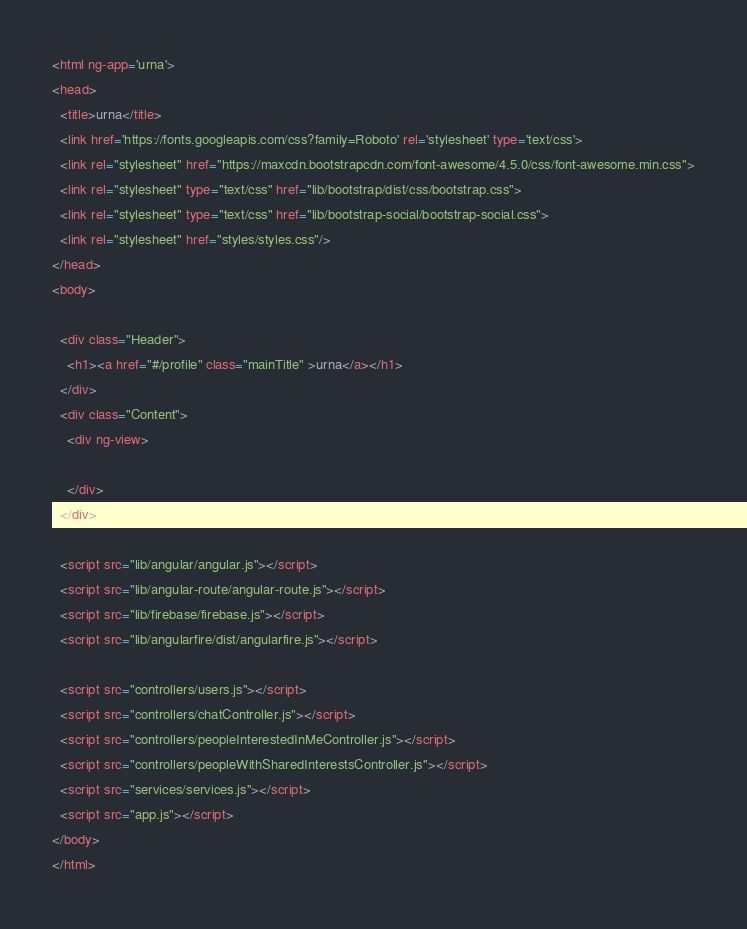Convert code to text. <code><loc_0><loc_0><loc_500><loc_500><_HTML_><html ng-app='urna'>
<head>
  <title>urna</title>
  <link href='https://fonts.googleapis.com/css?family=Roboto' rel='stylesheet' type='text/css'>
  <link rel="stylesheet" href="https://maxcdn.bootstrapcdn.com/font-awesome/4.5.0/css/font-awesome.min.css">
  <link rel="stylesheet" type="text/css" href="lib/bootstrap/dist/css/bootstrap.css">
  <link rel="stylesheet" type="text/css" href="lib/bootstrap-social/bootstrap-social.css">
  <link rel="stylesheet" href="styles/styles.css"/>
</head>
<body>

  <div class="Header">
    <h1><a href="#/profile" class="mainTitle" >urna</a></h1>
  </div>
  <div class="Content">
    <div ng-view>
      
    </div>
  </div>
  
  <script src="lib/angular/angular.js"></script>
  <script src="lib/angular-route/angular-route.js"></script>
  <script src="lib/firebase/firebase.js"></script>
  <script src="lib/angularfire/dist/angularfire.js"></script>

  <script src="controllers/users.js"></script>
  <script src="controllers/chatController.js"></script>
  <script src="controllers/peopleInterestedInMeController.js"></script>
  <script src="controllers/peopleWithSharedInterestsController.js"></script>
  <script src="services/services.js"></script>
  <script src="app.js"></script>
</body>
</html></code> 